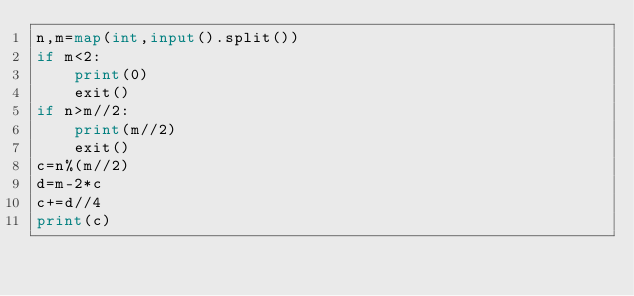<code> <loc_0><loc_0><loc_500><loc_500><_Python_>n,m=map(int,input().split())
if m<2:
    print(0)
    exit()
if n>m//2:
    print(m//2)
    exit()
c=n%(m//2)
d=m-2*c
c+=d//4
print(c)
</code> 